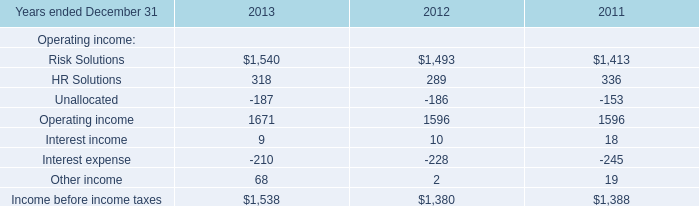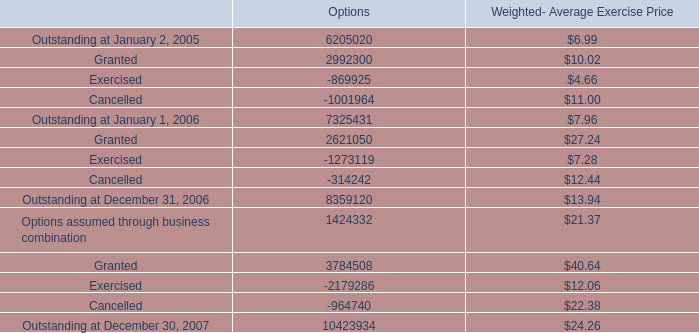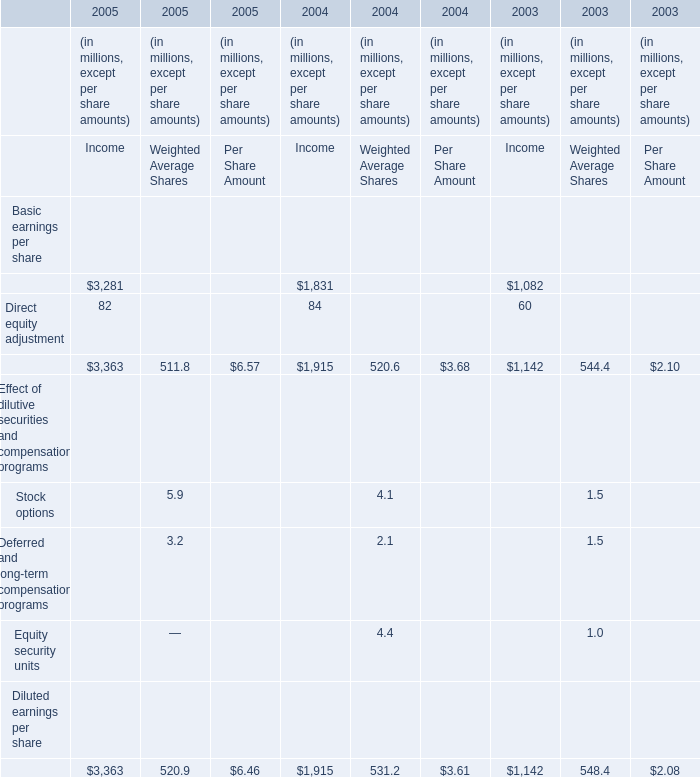what is the total value of granted options in 2007 , in millions? 
Computations: ((3784508 * 40.64) / 1000000)
Answer: 153.80241. 